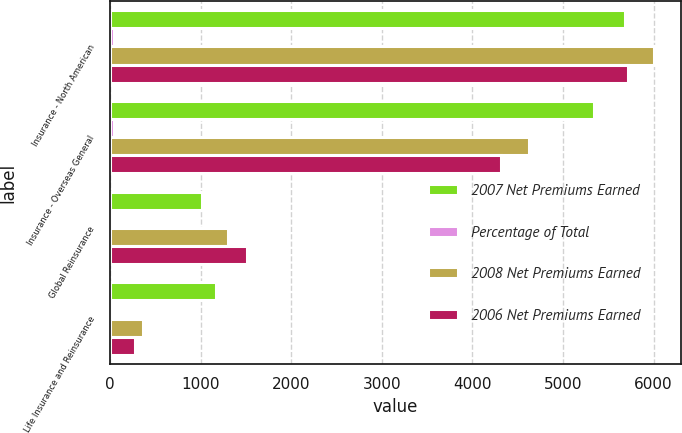Convert chart. <chart><loc_0><loc_0><loc_500><loc_500><stacked_bar_chart><ecel><fcel>Insurance - North American<fcel>Insurance - Overseas General<fcel>Global Reinsurance<fcel>Life Insurance and Reinsurance<nl><fcel>2007 Net Premiums Earned<fcel>5679<fcel>5337<fcel>1017<fcel>1170<nl><fcel>Percentage of Total<fcel>43<fcel>40<fcel>8<fcel>9<nl><fcel>2008 Net Premiums Earned<fcel>6007<fcel>4623<fcel>1299<fcel>368<nl><fcel>2006 Net Premiums Earned<fcel>5719<fcel>4321<fcel>1511<fcel>274<nl></chart> 